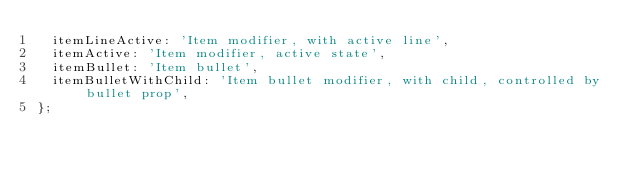Convert code to text. <code><loc_0><loc_0><loc_500><loc_500><_TypeScript_>  itemLineActive: 'Item modifier, with active line',
  itemActive: 'Item modifier, active state',
  itemBullet: 'Item bullet',
  itemBulletWithChild: 'Item bullet modifier, with child, controlled by bullet prop',
};
</code> 